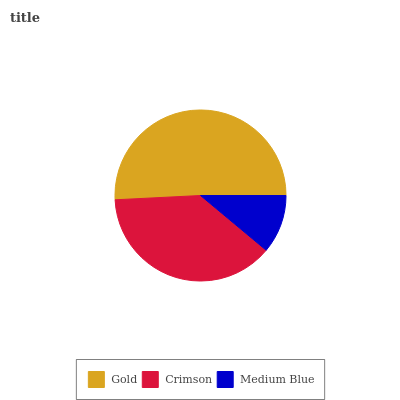Is Medium Blue the minimum?
Answer yes or no. Yes. Is Gold the maximum?
Answer yes or no. Yes. Is Crimson the minimum?
Answer yes or no. No. Is Crimson the maximum?
Answer yes or no. No. Is Gold greater than Crimson?
Answer yes or no. Yes. Is Crimson less than Gold?
Answer yes or no. Yes. Is Crimson greater than Gold?
Answer yes or no. No. Is Gold less than Crimson?
Answer yes or no. No. Is Crimson the high median?
Answer yes or no. Yes. Is Crimson the low median?
Answer yes or no. Yes. Is Medium Blue the high median?
Answer yes or no. No. Is Medium Blue the low median?
Answer yes or no. No. 